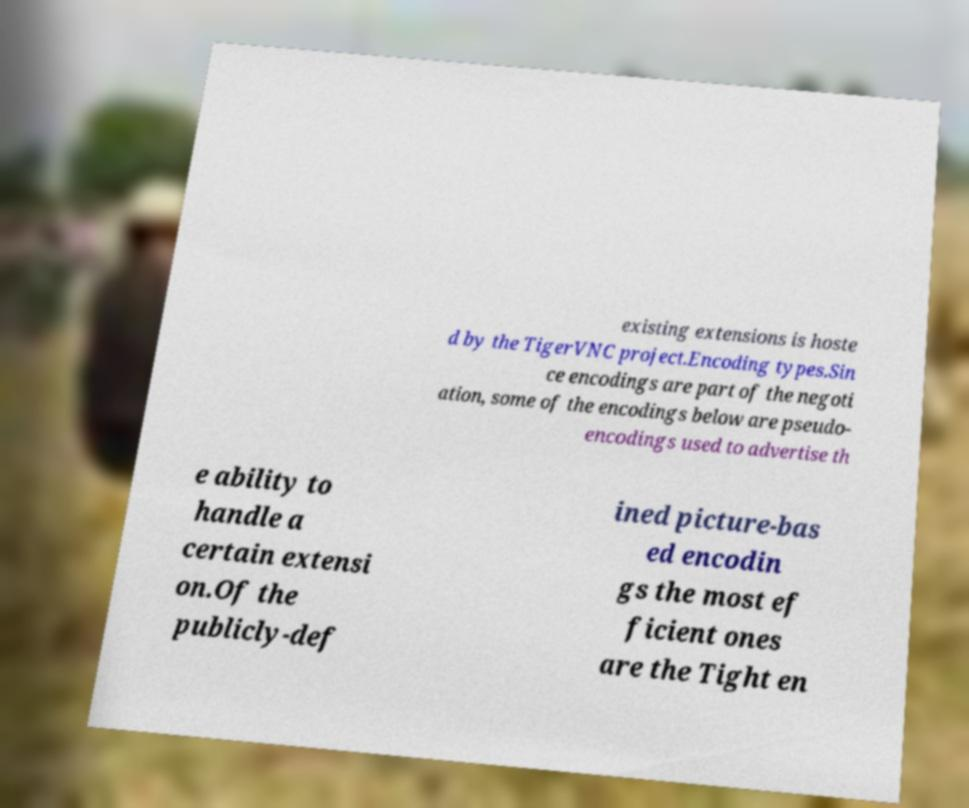Could you extract and type out the text from this image? existing extensions is hoste d by the TigerVNC project.Encoding types.Sin ce encodings are part of the negoti ation, some of the encodings below are pseudo- encodings used to advertise th e ability to handle a certain extensi on.Of the publicly-def ined picture-bas ed encodin gs the most ef ficient ones are the Tight en 